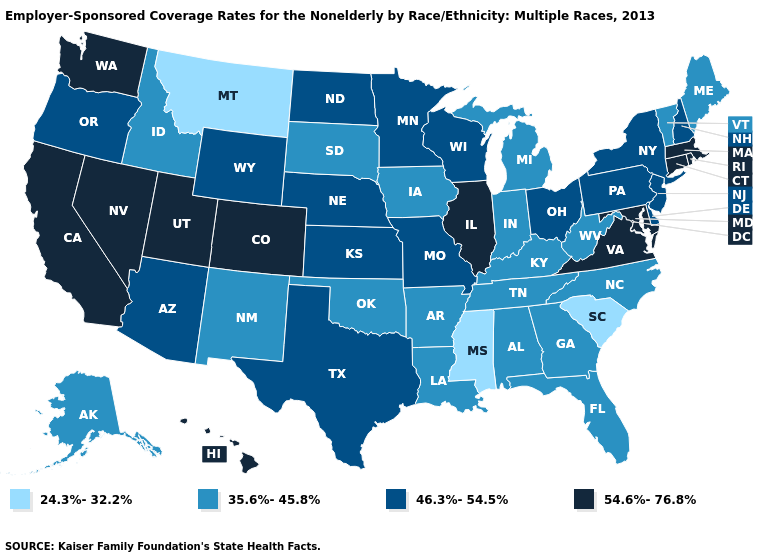What is the value of Pennsylvania?
Be succinct. 46.3%-54.5%. Does Georgia have the same value as Wyoming?
Give a very brief answer. No. What is the highest value in the West ?
Give a very brief answer. 54.6%-76.8%. What is the highest value in states that border Vermont?
Short answer required. 54.6%-76.8%. Name the states that have a value in the range 46.3%-54.5%?
Give a very brief answer. Arizona, Delaware, Kansas, Minnesota, Missouri, Nebraska, New Hampshire, New Jersey, New York, North Dakota, Ohio, Oregon, Pennsylvania, Texas, Wisconsin, Wyoming. Among the states that border Iowa , which have the highest value?
Answer briefly. Illinois. What is the value of Arizona?
Be succinct. 46.3%-54.5%. Name the states that have a value in the range 46.3%-54.5%?
Give a very brief answer. Arizona, Delaware, Kansas, Minnesota, Missouri, Nebraska, New Hampshire, New Jersey, New York, North Dakota, Ohio, Oregon, Pennsylvania, Texas, Wisconsin, Wyoming. Is the legend a continuous bar?
Be succinct. No. What is the lowest value in the USA?
Give a very brief answer. 24.3%-32.2%. Which states have the lowest value in the USA?
Quick response, please. Mississippi, Montana, South Carolina. Is the legend a continuous bar?
Write a very short answer. No. Name the states that have a value in the range 24.3%-32.2%?
Quick response, please. Mississippi, Montana, South Carolina. Which states have the highest value in the USA?
Write a very short answer. California, Colorado, Connecticut, Hawaii, Illinois, Maryland, Massachusetts, Nevada, Rhode Island, Utah, Virginia, Washington. Name the states that have a value in the range 24.3%-32.2%?
Answer briefly. Mississippi, Montana, South Carolina. 